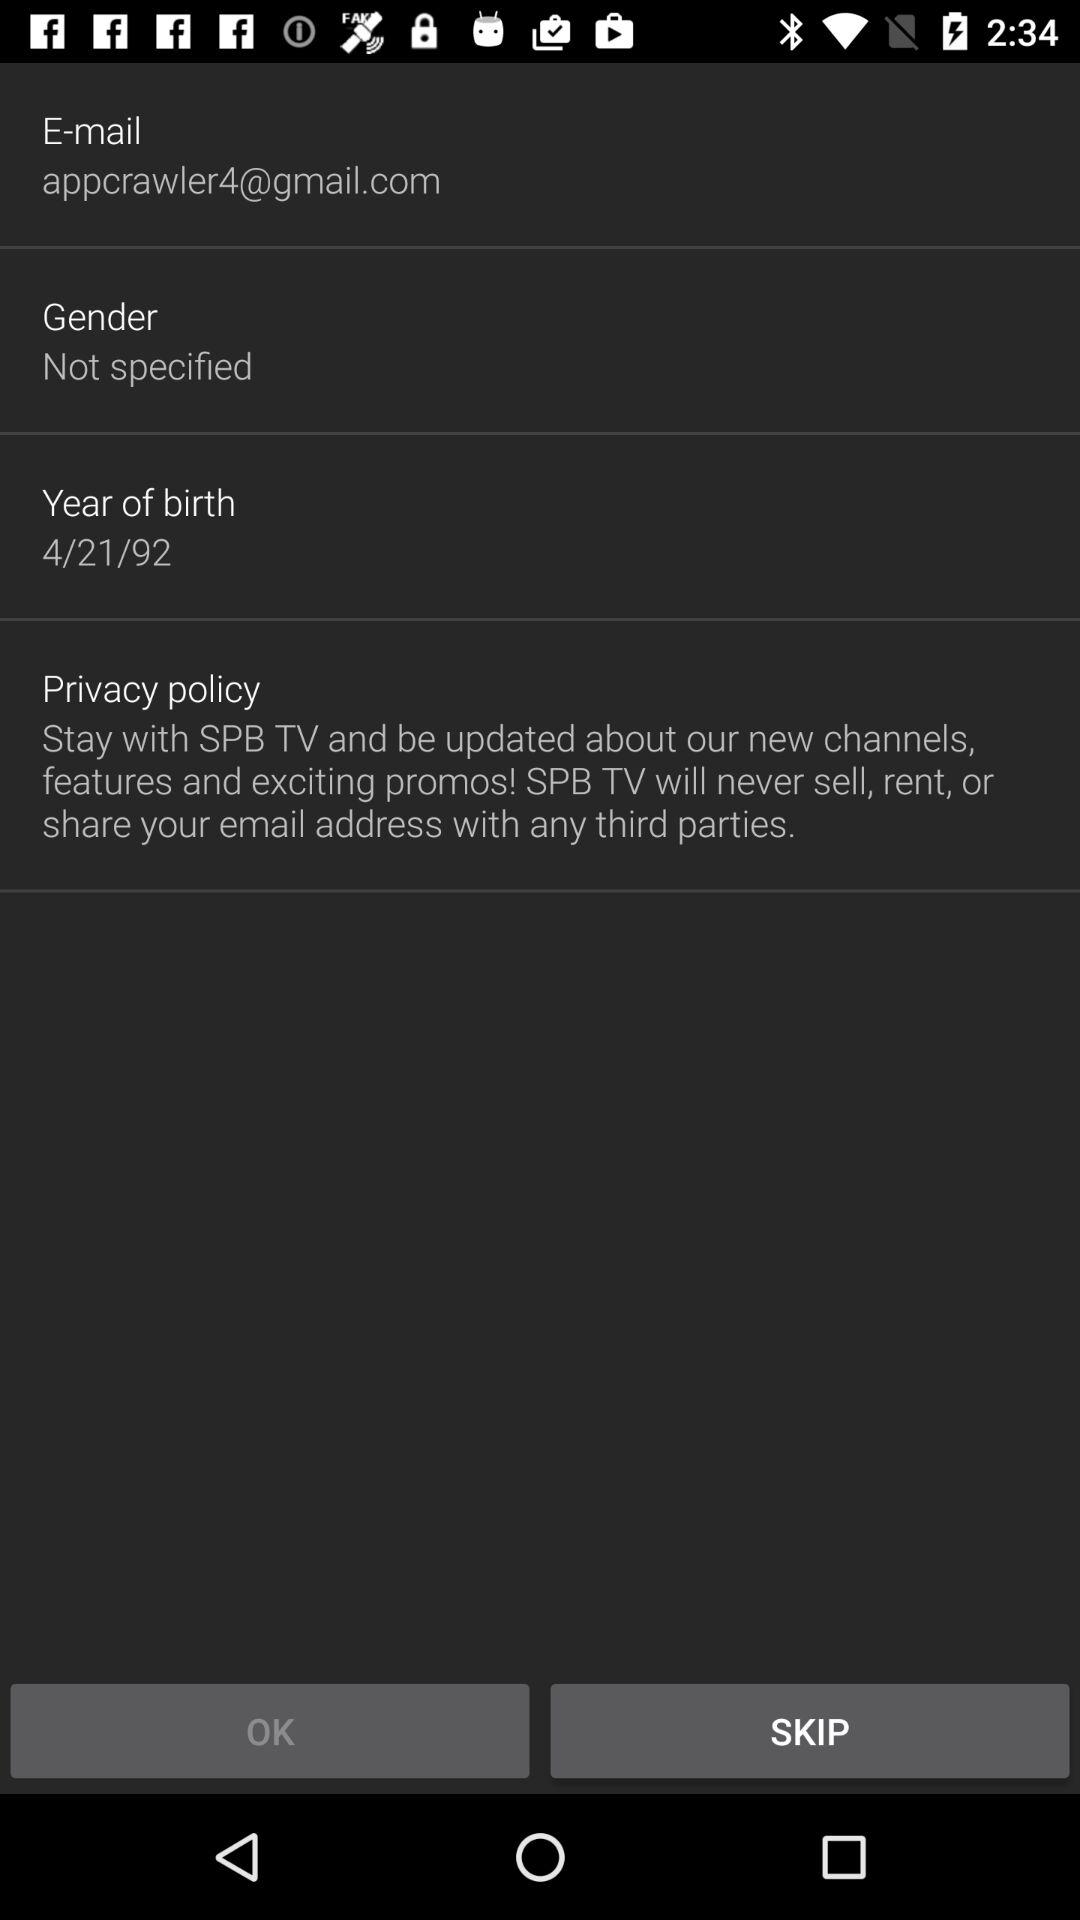What is the privacy policy? The privacy policy is "Stay with SPB TV and be updated about our new channels, features and exciting promos! SPB TV will never sell, rent, or share your email address with any third parties.". 